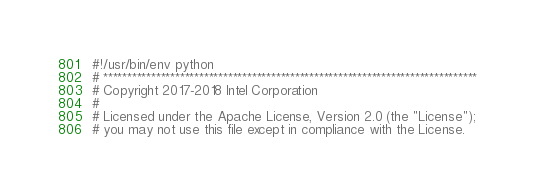Convert code to text. <code><loc_0><loc_0><loc_500><loc_500><_Python_>#!/usr/bin/env python
# ******************************************************************************
# Copyright 2017-2018 Intel Corporation
#
# Licensed under the Apache License, Version 2.0 (the "License");
# you may not use this file except in compliance with the License.</code> 